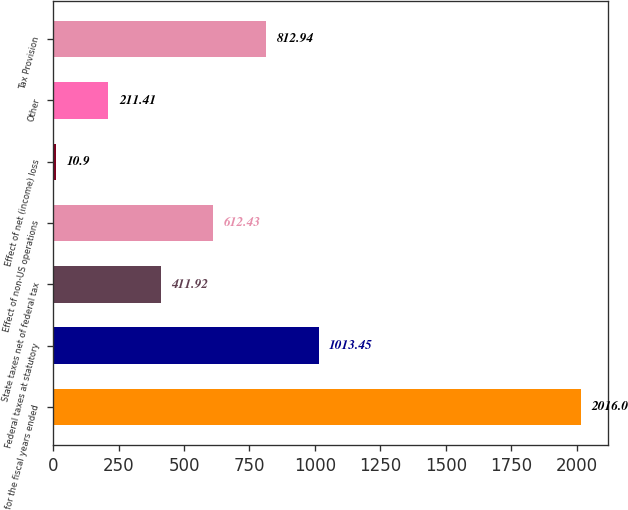<chart> <loc_0><loc_0><loc_500><loc_500><bar_chart><fcel>for the fiscal years ended<fcel>Federal taxes at statutory<fcel>State taxes net of federal tax<fcel>Effect of non-US operations<fcel>Effect of net (income) loss<fcel>Other<fcel>Tax Provision<nl><fcel>2016<fcel>1013.45<fcel>411.92<fcel>612.43<fcel>10.9<fcel>211.41<fcel>812.94<nl></chart> 